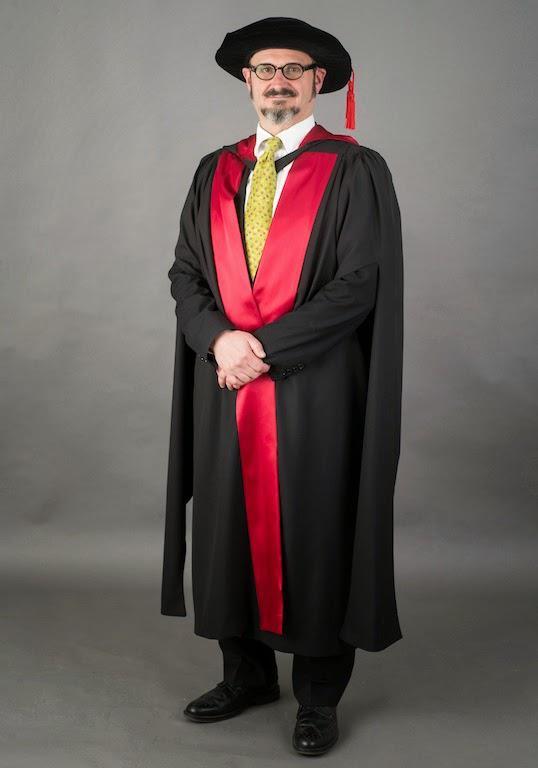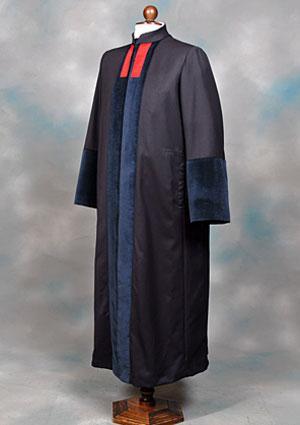The first image is the image on the left, the second image is the image on the right. Analyze the images presented: Is the assertion "The left image shows exactly one male in graduation garb." valid? Answer yes or no. Yes. 